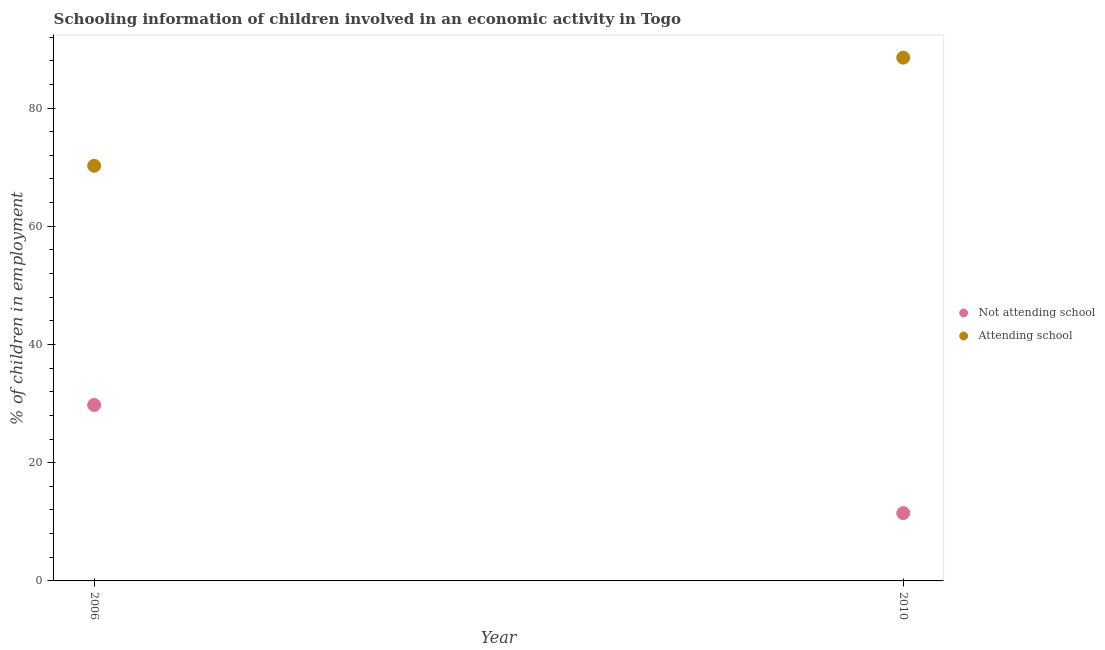How many different coloured dotlines are there?
Provide a succinct answer. 2. Is the number of dotlines equal to the number of legend labels?
Keep it short and to the point. Yes. What is the percentage of employed children who are not attending school in 2010?
Keep it short and to the point. 11.47. Across all years, what is the maximum percentage of employed children who are not attending school?
Your response must be concise. 29.76. Across all years, what is the minimum percentage of employed children who are not attending school?
Your answer should be very brief. 11.47. In which year was the percentage of employed children who are not attending school maximum?
Give a very brief answer. 2006. In which year was the percentage of employed children who are attending school minimum?
Your answer should be very brief. 2006. What is the total percentage of employed children who are not attending school in the graph?
Your answer should be compact. 41.23. What is the difference between the percentage of employed children who are attending school in 2006 and that in 2010?
Your response must be concise. -18.29. What is the difference between the percentage of employed children who are not attending school in 2010 and the percentage of employed children who are attending school in 2006?
Offer a very short reply. -58.77. What is the average percentage of employed children who are not attending school per year?
Give a very brief answer. 20.62. In the year 2006, what is the difference between the percentage of employed children who are not attending school and percentage of employed children who are attending school?
Offer a very short reply. -40.47. What is the ratio of the percentage of employed children who are attending school in 2006 to that in 2010?
Make the answer very short. 0.79. Is the percentage of employed children who are attending school in 2006 less than that in 2010?
Provide a short and direct response. Yes. How many years are there in the graph?
Your response must be concise. 2. Does the graph contain any zero values?
Offer a terse response. No. Does the graph contain grids?
Your response must be concise. No. Where does the legend appear in the graph?
Your answer should be very brief. Center right. How many legend labels are there?
Offer a very short reply. 2. What is the title of the graph?
Offer a very short reply. Schooling information of children involved in an economic activity in Togo. What is the label or title of the Y-axis?
Your answer should be very brief. % of children in employment. What is the % of children in employment of Not attending school in 2006?
Give a very brief answer. 29.76. What is the % of children in employment of Attending school in 2006?
Make the answer very short. 70.24. What is the % of children in employment of Not attending school in 2010?
Offer a terse response. 11.47. What is the % of children in employment in Attending school in 2010?
Provide a succinct answer. 88.53. Across all years, what is the maximum % of children in employment of Not attending school?
Your answer should be very brief. 29.76. Across all years, what is the maximum % of children in employment of Attending school?
Your response must be concise. 88.53. Across all years, what is the minimum % of children in employment of Not attending school?
Provide a succinct answer. 11.47. Across all years, what is the minimum % of children in employment of Attending school?
Provide a short and direct response. 70.24. What is the total % of children in employment in Not attending school in the graph?
Make the answer very short. 41.23. What is the total % of children in employment of Attending school in the graph?
Ensure brevity in your answer.  158.77. What is the difference between the % of children in employment in Not attending school in 2006 and that in 2010?
Provide a short and direct response. 18.29. What is the difference between the % of children in employment of Attending school in 2006 and that in 2010?
Make the answer very short. -18.29. What is the difference between the % of children in employment in Not attending school in 2006 and the % of children in employment in Attending school in 2010?
Make the answer very short. -58.77. What is the average % of children in employment in Not attending school per year?
Offer a very short reply. 20.62. What is the average % of children in employment of Attending school per year?
Offer a terse response. 79.38. In the year 2006, what is the difference between the % of children in employment in Not attending school and % of children in employment in Attending school?
Ensure brevity in your answer.  -40.47. In the year 2010, what is the difference between the % of children in employment in Not attending school and % of children in employment in Attending school?
Keep it short and to the point. -77.06. What is the ratio of the % of children in employment in Not attending school in 2006 to that in 2010?
Offer a very short reply. 2.59. What is the ratio of the % of children in employment of Attending school in 2006 to that in 2010?
Give a very brief answer. 0.79. What is the difference between the highest and the second highest % of children in employment of Not attending school?
Give a very brief answer. 18.29. What is the difference between the highest and the second highest % of children in employment of Attending school?
Keep it short and to the point. 18.29. What is the difference between the highest and the lowest % of children in employment in Not attending school?
Make the answer very short. 18.29. What is the difference between the highest and the lowest % of children in employment of Attending school?
Ensure brevity in your answer.  18.29. 